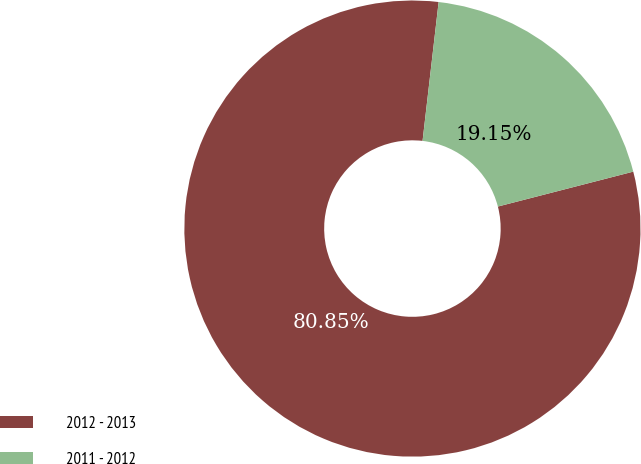<chart> <loc_0><loc_0><loc_500><loc_500><pie_chart><fcel>2012 - 2013<fcel>2011 - 2012<nl><fcel>80.85%<fcel>19.15%<nl></chart> 